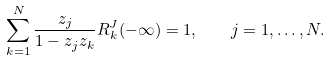<formula> <loc_0><loc_0><loc_500><loc_500>\sum _ { k = 1 } ^ { N } \frac { z _ { j } } { 1 - z _ { j } z _ { k } } R _ { k } ^ { J } ( - \infty ) = 1 , \quad j = 1 , \dots , N .</formula> 